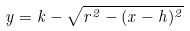<formula> <loc_0><loc_0><loc_500><loc_500>y = k - \sqrt { r ^ { 2 } - ( x - h ) ^ { 2 } }</formula> 